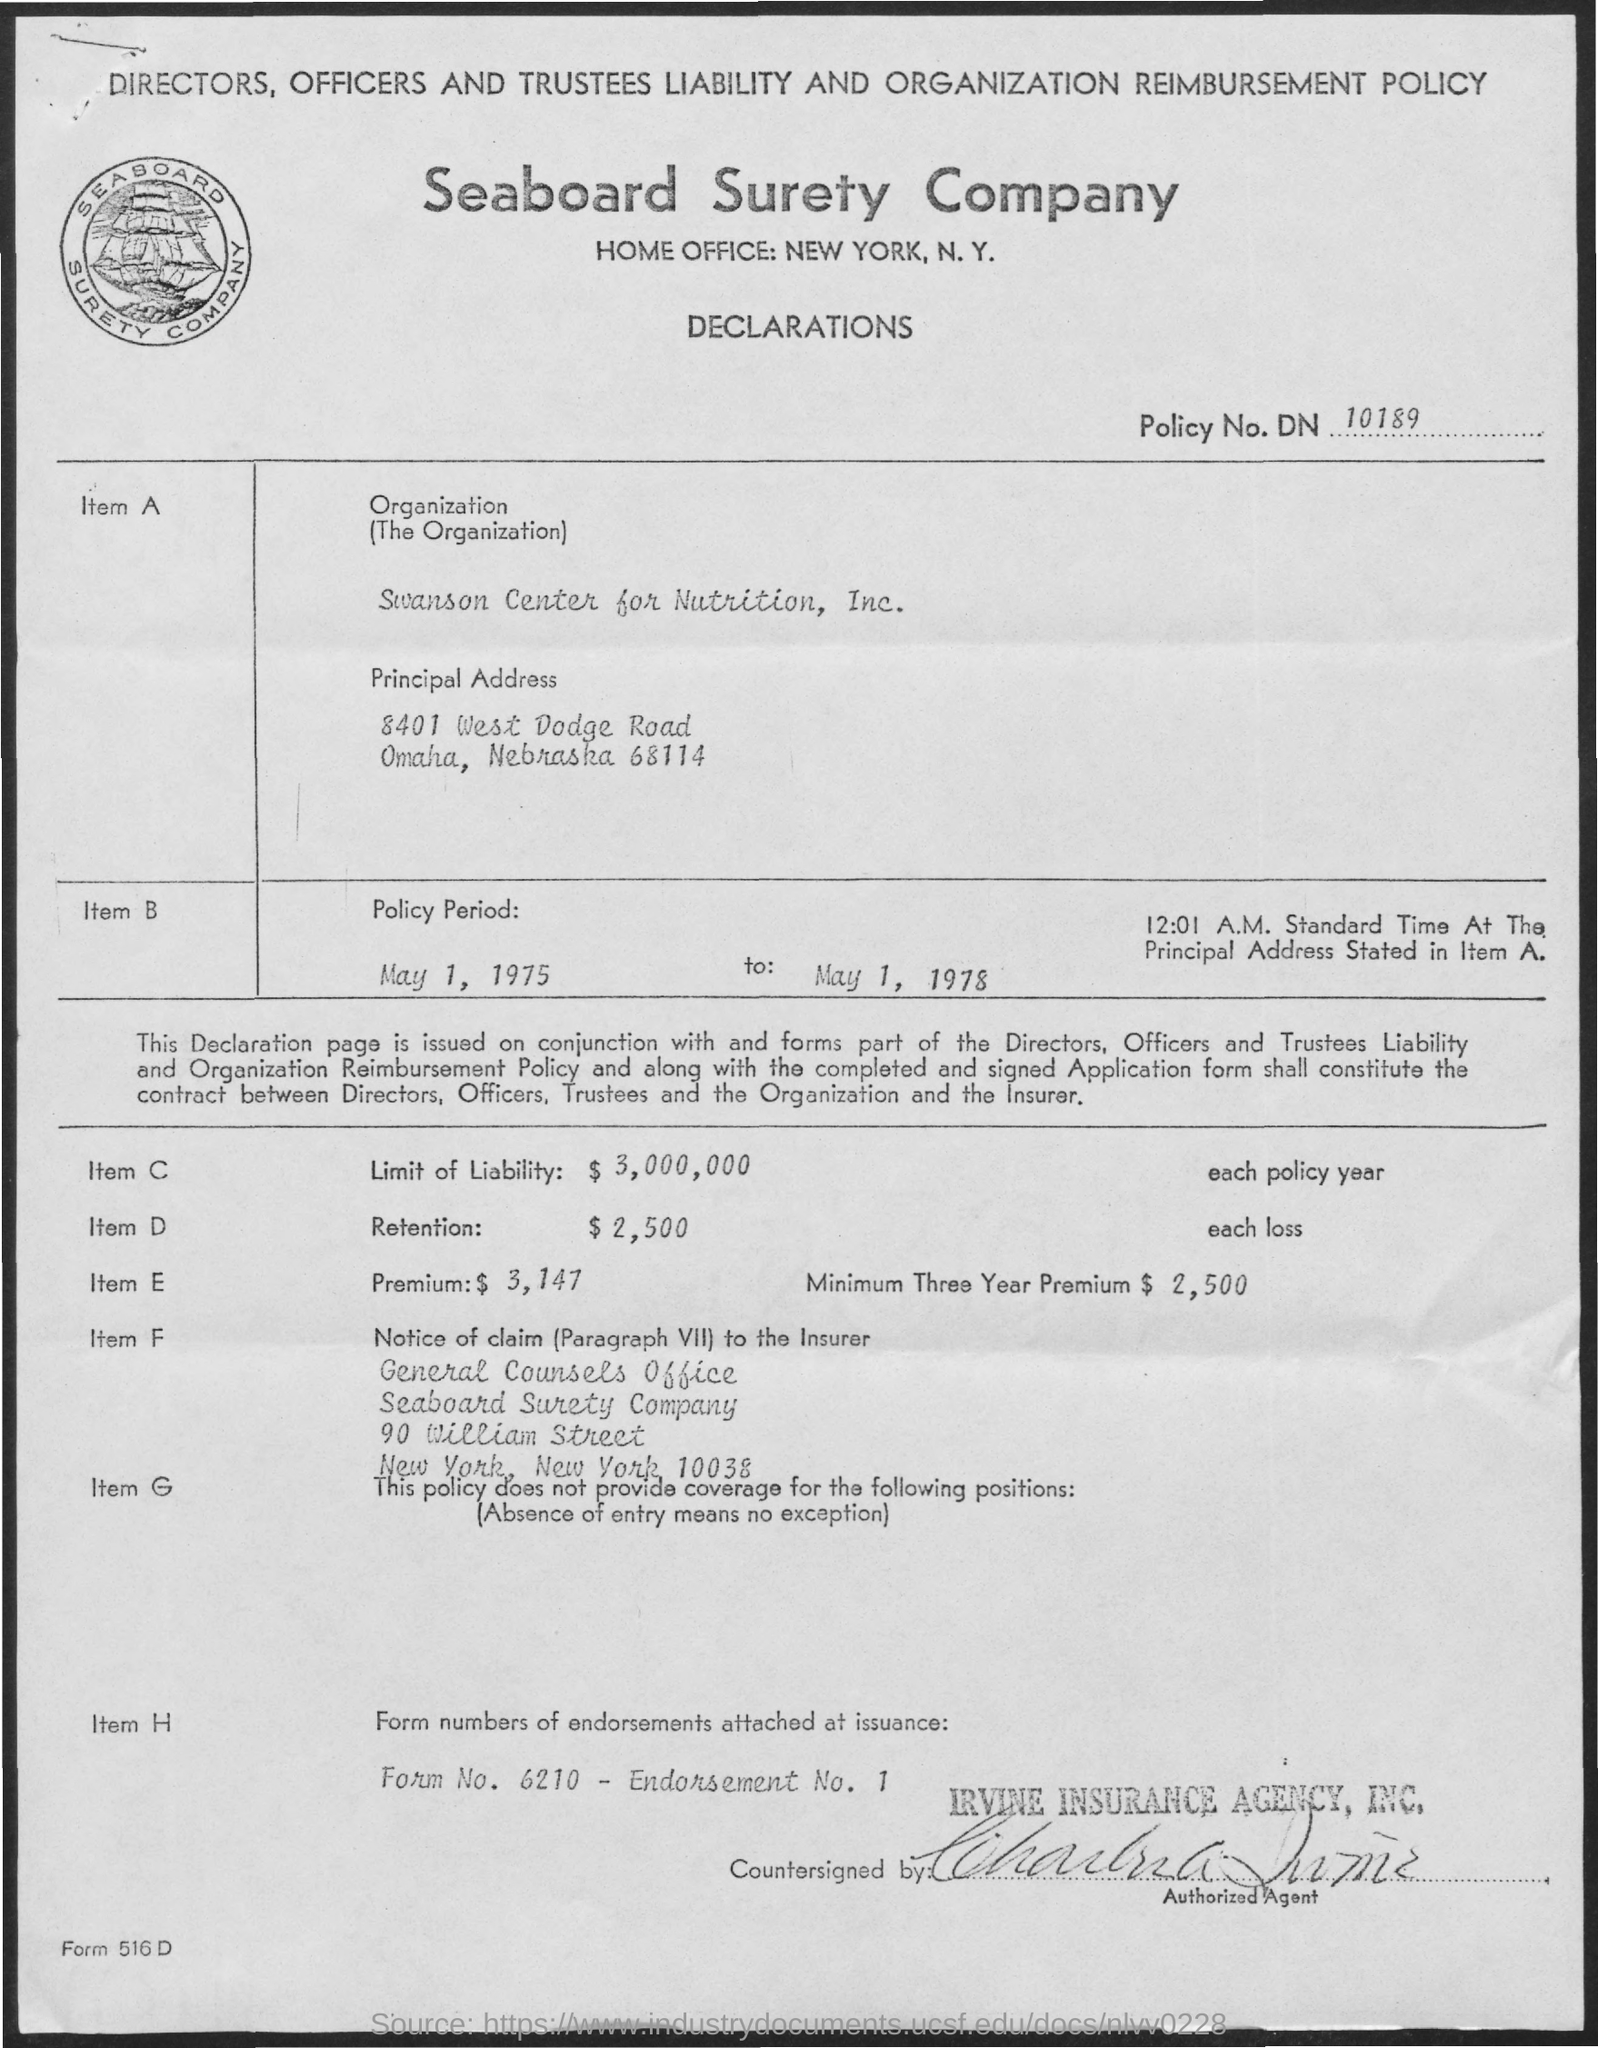what is the name of the company mentioned ?
 Seaboard Surety Company 